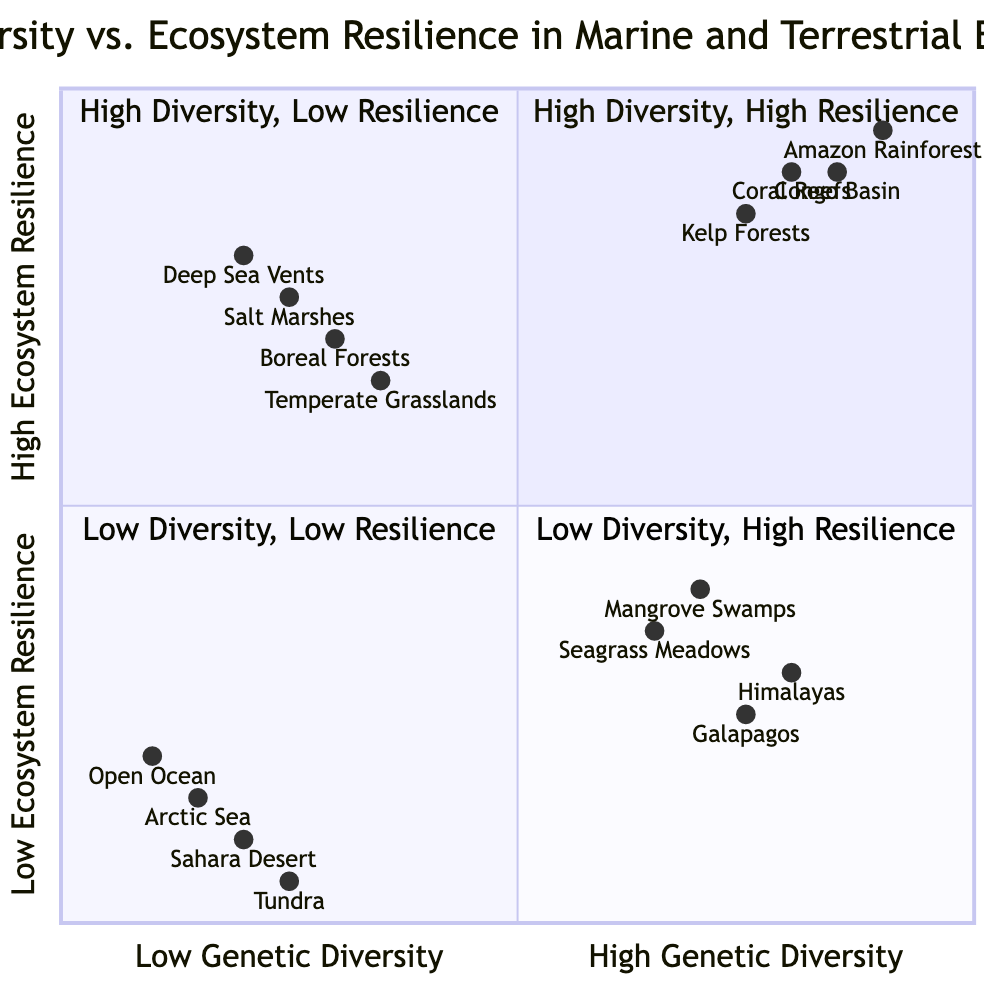What are two examples of marine environments with high genetic diversity and high ecosystem resilience? The diagram indicates that the marine environments in the "High Genetic Diversity - High Ecosystem Resilience" quadrant are Coral Reefs (Great Barrier Reef) and Kelp Forests (Pacific Coast).
Answer: Coral Reefs, Kelp Forests How many examples are shown in the low genetic diversity and low ecosystem resilience quadrant? The diagram specifies that there are four examples listed in the "Low Genetic Diversity - Low Ecosystem Resilience" quadrant: Open Ocean (North Atlantic), Polar Ice Regions (Arctic Sea), Deserts (Sahara Desert), and Tundra (Alaska).
Answer: Four Which terrestrial environment has high genetic diversity and low ecosystem resilience? According to the diagram, the terrestrial environment categorized under "High Genetic Diversity - Low Ecosystem Resilience" includes Mountainous Regions (Himalayas) and Isolated Island Ecosystems (Galapagos).
Answer: Mountainous Regions, Isolated Island Ecosystems What is the genetic diversity of Coral Reefs as shown in the diagram? The data provided for Coral Reefs indicates a genetic diversity value of 0.8, which falls in the "High Genetic Diversity - High Ecosystem Resilience" quadrant.
Answer: 0.8 Why do the Boreal Forests have high ecosystem resilience despite low genetic diversity? Boreal Forests are positioned in the "Low Genetic Diversity - High Ecosystem Resilience" quadrant as indicated on the diagram. This suggests that despite their low genetic diversity (0.3), they exhibit stronger ecosystem resilience factors, possibly due to long-term stability and adaptability to the environment.
Answer: Adaptability to the environment What is the relationship between the genetic diversity of Seagrass Meadows and their ecosystem resilience? Seagrass Meadows have a genetic diversity of 0.65 and an ecosystem resilience value of 0.35, which places them in the "High Genetic Diversity - Low Ecosystem Resilience" quadrant. This suggests a notable difference where their genetic diversity does not translate to high resilience.
Answer: Low resilience despite high diversity Which marine environment is characterized by low genetic diversity and high ecosystem resilience? The diagram shows that Salt Marshes (Gulf of Mexico) fall into the "Low Genetic Diversity - High Ecosystem Resilience" quadrant with a genetic diversity value of 0.25 and a resilience value of 0.75.
Answer: Salt Marshes 